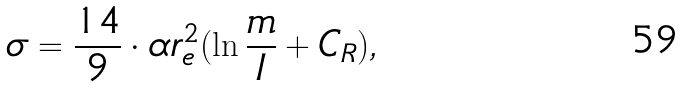<formula> <loc_0><loc_0><loc_500><loc_500>\sigma = \frac { 1 4 } { 9 } \cdot \alpha r _ { e } ^ { 2 } ( \ln \frac { m } { I } + C _ { R } ) ,</formula> 